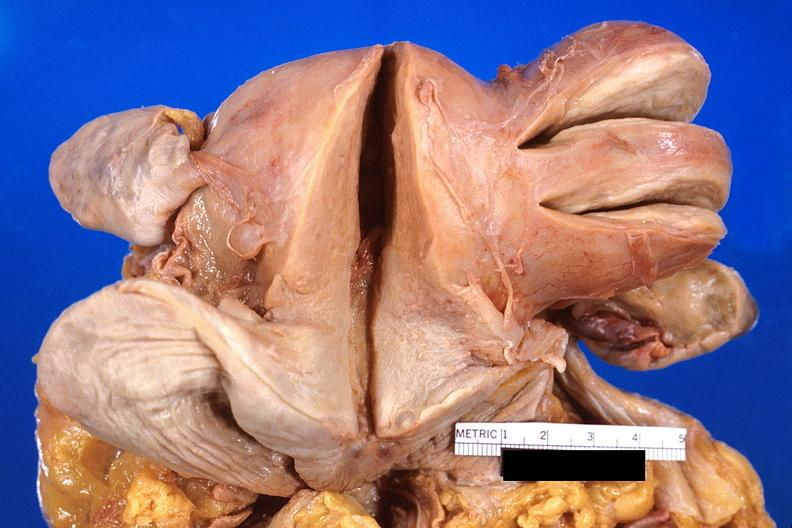does muscle atrophy show uterus, leiomyoma?
Answer the question using a single word or phrase. No 